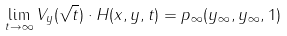<formula> <loc_0><loc_0><loc_500><loc_500>\lim _ { t \rightarrow \infty } V _ { y } ( \sqrt { t } ) \cdot H ( x , y , t ) = p _ { \infty } ( y _ { \infty } , y _ { \infty } , 1 )</formula> 